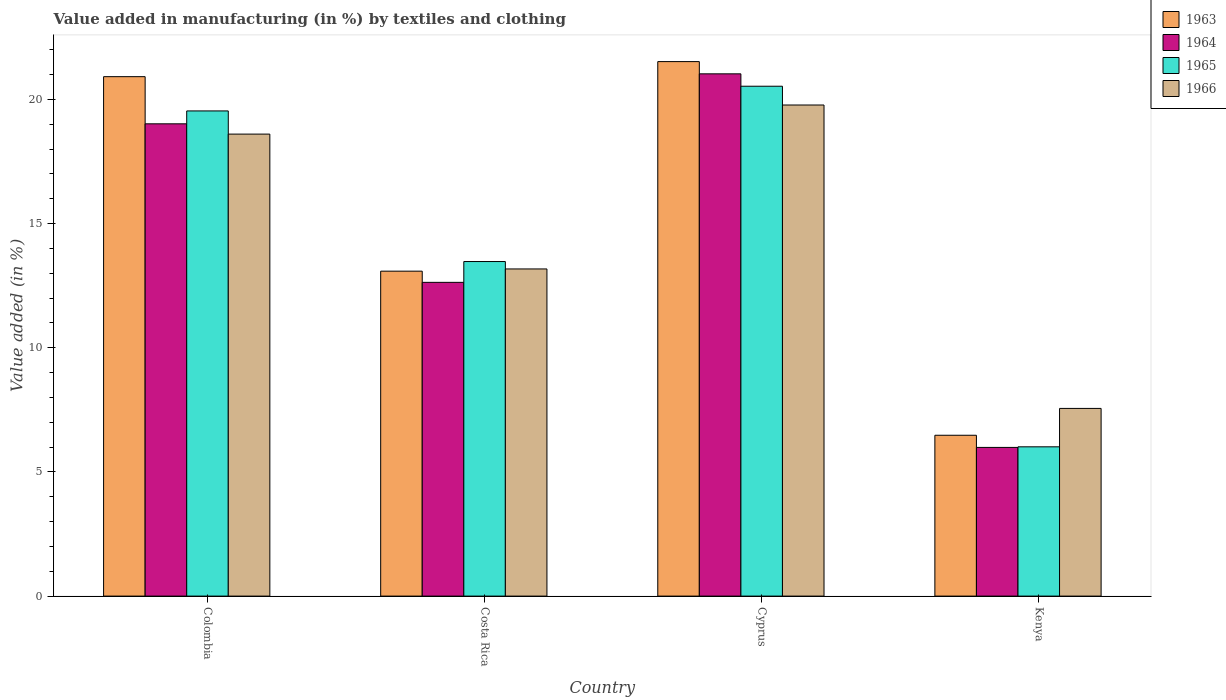How many different coloured bars are there?
Give a very brief answer. 4. How many groups of bars are there?
Ensure brevity in your answer.  4. How many bars are there on the 1st tick from the left?
Ensure brevity in your answer.  4. How many bars are there on the 1st tick from the right?
Make the answer very short. 4. What is the percentage of value added in manufacturing by textiles and clothing in 1964 in Colombia?
Offer a very short reply. 19.02. Across all countries, what is the maximum percentage of value added in manufacturing by textiles and clothing in 1966?
Provide a short and direct response. 19.78. Across all countries, what is the minimum percentage of value added in manufacturing by textiles and clothing in 1965?
Your answer should be compact. 6.01. In which country was the percentage of value added in manufacturing by textiles and clothing in 1963 maximum?
Give a very brief answer. Cyprus. In which country was the percentage of value added in manufacturing by textiles and clothing in 1963 minimum?
Provide a short and direct response. Kenya. What is the total percentage of value added in manufacturing by textiles and clothing in 1963 in the graph?
Provide a succinct answer. 62. What is the difference between the percentage of value added in manufacturing by textiles and clothing in 1965 in Cyprus and that in Kenya?
Your answer should be very brief. 14.52. What is the difference between the percentage of value added in manufacturing by textiles and clothing in 1966 in Costa Rica and the percentage of value added in manufacturing by textiles and clothing in 1963 in Colombia?
Your answer should be very brief. -7.74. What is the average percentage of value added in manufacturing by textiles and clothing in 1966 per country?
Offer a terse response. 14.78. What is the difference between the percentage of value added in manufacturing by textiles and clothing of/in 1964 and percentage of value added in manufacturing by textiles and clothing of/in 1963 in Kenya?
Offer a terse response. -0.49. What is the ratio of the percentage of value added in manufacturing by textiles and clothing in 1964 in Colombia to that in Cyprus?
Keep it short and to the point. 0.9. Is the percentage of value added in manufacturing by textiles and clothing in 1965 in Colombia less than that in Costa Rica?
Ensure brevity in your answer.  No. What is the difference between the highest and the second highest percentage of value added in manufacturing by textiles and clothing in 1965?
Offer a terse response. -0.99. What is the difference between the highest and the lowest percentage of value added in manufacturing by textiles and clothing in 1966?
Your answer should be compact. 12.22. Is it the case that in every country, the sum of the percentage of value added in manufacturing by textiles and clothing in 1966 and percentage of value added in manufacturing by textiles and clothing in 1963 is greater than the sum of percentage of value added in manufacturing by textiles and clothing in 1964 and percentage of value added in manufacturing by textiles and clothing in 1965?
Give a very brief answer. No. What does the 3rd bar from the right in Kenya represents?
Offer a terse response. 1964. Is it the case that in every country, the sum of the percentage of value added in manufacturing by textiles and clothing in 1963 and percentage of value added in manufacturing by textiles and clothing in 1965 is greater than the percentage of value added in manufacturing by textiles and clothing in 1966?
Your answer should be compact. Yes. Does the graph contain any zero values?
Provide a short and direct response. No. Does the graph contain grids?
Your response must be concise. No. How are the legend labels stacked?
Your response must be concise. Vertical. What is the title of the graph?
Your response must be concise. Value added in manufacturing (in %) by textiles and clothing. What is the label or title of the Y-axis?
Offer a terse response. Value added (in %). What is the Value added (in %) in 1963 in Colombia?
Offer a very short reply. 20.92. What is the Value added (in %) of 1964 in Colombia?
Provide a short and direct response. 19.02. What is the Value added (in %) of 1965 in Colombia?
Offer a terse response. 19.54. What is the Value added (in %) in 1966 in Colombia?
Your answer should be very brief. 18.6. What is the Value added (in %) of 1963 in Costa Rica?
Ensure brevity in your answer.  13.08. What is the Value added (in %) in 1964 in Costa Rica?
Your answer should be very brief. 12.63. What is the Value added (in %) of 1965 in Costa Rica?
Your response must be concise. 13.47. What is the Value added (in %) in 1966 in Costa Rica?
Make the answer very short. 13.17. What is the Value added (in %) of 1963 in Cyprus?
Your answer should be compact. 21.52. What is the Value added (in %) of 1964 in Cyprus?
Keep it short and to the point. 21.03. What is the Value added (in %) of 1965 in Cyprus?
Give a very brief answer. 20.53. What is the Value added (in %) of 1966 in Cyprus?
Offer a very short reply. 19.78. What is the Value added (in %) of 1963 in Kenya?
Keep it short and to the point. 6.48. What is the Value added (in %) in 1964 in Kenya?
Offer a terse response. 5.99. What is the Value added (in %) in 1965 in Kenya?
Your answer should be very brief. 6.01. What is the Value added (in %) in 1966 in Kenya?
Your answer should be very brief. 7.56. Across all countries, what is the maximum Value added (in %) in 1963?
Keep it short and to the point. 21.52. Across all countries, what is the maximum Value added (in %) of 1964?
Make the answer very short. 21.03. Across all countries, what is the maximum Value added (in %) of 1965?
Your response must be concise. 20.53. Across all countries, what is the maximum Value added (in %) in 1966?
Your response must be concise. 19.78. Across all countries, what is the minimum Value added (in %) in 1963?
Provide a short and direct response. 6.48. Across all countries, what is the minimum Value added (in %) of 1964?
Make the answer very short. 5.99. Across all countries, what is the minimum Value added (in %) of 1965?
Ensure brevity in your answer.  6.01. Across all countries, what is the minimum Value added (in %) in 1966?
Ensure brevity in your answer.  7.56. What is the total Value added (in %) in 1963 in the graph?
Offer a terse response. 62. What is the total Value added (in %) of 1964 in the graph?
Your answer should be compact. 58.67. What is the total Value added (in %) in 1965 in the graph?
Give a very brief answer. 59.55. What is the total Value added (in %) in 1966 in the graph?
Ensure brevity in your answer.  59.11. What is the difference between the Value added (in %) in 1963 in Colombia and that in Costa Rica?
Provide a short and direct response. 7.83. What is the difference between the Value added (in %) in 1964 in Colombia and that in Costa Rica?
Provide a succinct answer. 6.38. What is the difference between the Value added (in %) in 1965 in Colombia and that in Costa Rica?
Your response must be concise. 6.06. What is the difference between the Value added (in %) in 1966 in Colombia and that in Costa Rica?
Ensure brevity in your answer.  5.43. What is the difference between the Value added (in %) in 1963 in Colombia and that in Cyprus?
Provide a short and direct response. -0.61. What is the difference between the Value added (in %) of 1964 in Colombia and that in Cyprus?
Offer a terse response. -2.01. What is the difference between the Value added (in %) of 1965 in Colombia and that in Cyprus?
Provide a succinct answer. -0.99. What is the difference between the Value added (in %) in 1966 in Colombia and that in Cyprus?
Make the answer very short. -1.17. What is the difference between the Value added (in %) in 1963 in Colombia and that in Kenya?
Make the answer very short. 14.44. What is the difference between the Value added (in %) of 1964 in Colombia and that in Kenya?
Your answer should be very brief. 13.03. What is the difference between the Value added (in %) of 1965 in Colombia and that in Kenya?
Offer a very short reply. 13.53. What is the difference between the Value added (in %) in 1966 in Colombia and that in Kenya?
Your answer should be compact. 11.05. What is the difference between the Value added (in %) in 1963 in Costa Rica and that in Cyprus?
Provide a succinct answer. -8.44. What is the difference between the Value added (in %) of 1964 in Costa Rica and that in Cyprus?
Provide a succinct answer. -8.4. What is the difference between the Value added (in %) in 1965 in Costa Rica and that in Cyprus?
Give a very brief answer. -7.06. What is the difference between the Value added (in %) of 1966 in Costa Rica and that in Cyprus?
Provide a succinct answer. -6.6. What is the difference between the Value added (in %) in 1963 in Costa Rica and that in Kenya?
Offer a very short reply. 6.61. What is the difference between the Value added (in %) in 1964 in Costa Rica and that in Kenya?
Offer a terse response. 6.65. What is the difference between the Value added (in %) of 1965 in Costa Rica and that in Kenya?
Provide a short and direct response. 7.46. What is the difference between the Value added (in %) in 1966 in Costa Rica and that in Kenya?
Offer a terse response. 5.62. What is the difference between the Value added (in %) in 1963 in Cyprus and that in Kenya?
Provide a short and direct response. 15.05. What is the difference between the Value added (in %) of 1964 in Cyprus and that in Kenya?
Your answer should be very brief. 15.04. What is the difference between the Value added (in %) in 1965 in Cyprus and that in Kenya?
Ensure brevity in your answer.  14.52. What is the difference between the Value added (in %) in 1966 in Cyprus and that in Kenya?
Offer a very short reply. 12.22. What is the difference between the Value added (in %) in 1963 in Colombia and the Value added (in %) in 1964 in Costa Rica?
Your answer should be very brief. 8.28. What is the difference between the Value added (in %) in 1963 in Colombia and the Value added (in %) in 1965 in Costa Rica?
Provide a succinct answer. 7.44. What is the difference between the Value added (in %) of 1963 in Colombia and the Value added (in %) of 1966 in Costa Rica?
Your answer should be compact. 7.74. What is the difference between the Value added (in %) in 1964 in Colombia and the Value added (in %) in 1965 in Costa Rica?
Make the answer very short. 5.55. What is the difference between the Value added (in %) of 1964 in Colombia and the Value added (in %) of 1966 in Costa Rica?
Keep it short and to the point. 5.84. What is the difference between the Value added (in %) of 1965 in Colombia and the Value added (in %) of 1966 in Costa Rica?
Your response must be concise. 6.36. What is the difference between the Value added (in %) in 1963 in Colombia and the Value added (in %) in 1964 in Cyprus?
Your answer should be compact. -0.11. What is the difference between the Value added (in %) of 1963 in Colombia and the Value added (in %) of 1965 in Cyprus?
Offer a terse response. 0.39. What is the difference between the Value added (in %) in 1963 in Colombia and the Value added (in %) in 1966 in Cyprus?
Ensure brevity in your answer.  1.14. What is the difference between the Value added (in %) in 1964 in Colombia and the Value added (in %) in 1965 in Cyprus?
Your answer should be very brief. -1.51. What is the difference between the Value added (in %) of 1964 in Colombia and the Value added (in %) of 1966 in Cyprus?
Your answer should be compact. -0.76. What is the difference between the Value added (in %) in 1965 in Colombia and the Value added (in %) in 1966 in Cyprus?
Your response must be concise. -0.24. What is the difference between the Value added (in %) in 1963 in Colombia and the Value added (in %) in 1964 in Kenya?
Your answer should be compact. 14.93. What is the difference between the Value added (in %) of 1963 in Colombia and the Value added (in %) of 1965 in Kenya?
Give a very brief answer. 14.91. What is the difference between the Value added (in %) of 1963 in Colombia and the Value added (in %) of 1966 in Kenya?
Your answer should be compact. 13.36. What is the difference between the Value added (in %) of 1964 in Colombia and the Value added (in %) of 1965 in Kenya?
Your answer should be very brief. 13.01. What is the difference between the Value added (in %) in 1964 in Colombia and the Value added (in %) in 1966 in Kenya?
Your answer should be very brief. 11.46. What is the difference between the Value added (in %) in 1965 in Colombia and the Value added (in %) in 1966 in Kenya?
Offer a terse response. 11.98. What is the difference between the Value added (in %) in 1963 in Costa Rica and the Value added (in %) in 1964 in Cyprus?
Ensure brevity in your answer.  -7.95. What is the difference between the Value added (in %) in 1963 in Costa Rica and the Value added (in %) in 1965 in Cyprus?
Offer a very short reply. -7.45. What is the difference between the Value added (in %) in 1963 in Costa Rica and the Value added (in %) in 1966 in Cyprus?
Provide a short and direct response. -6.69. What is the difference between the Value added (in %) in 1964 in Costa Rica and the Value added (in %) in 1965 in Cyprus?
Ensure brevity in your answer.  -7.9. What is the difference between the Value added (in %) of 1964 in Costa Rica and the Value added (in %) of 1966 in Cyprus?
Give a very brief answer. -7.14. What is the difference between the Value added (in %) of 1965 in Costa Rica and the Value added (in %) of 1966 in Cyprus?
Provide a succinct answer. -6.3. What is the difference between the Value added (in %) in 1963 in Costa Rica and the Value added (in %) in 1964 in Kenya?
Provide a short and direct response. 7.1. What is the difference between the Value added (in %) in 1963 in Costa Rica and the Value added (in %) in 1965 in Kenya?
Provide a short and direct response. 7.07. What is the difference between the Value added (in %) of 1963 in Costa Rica and the Value added (in %) of 1966 in Kenya?
Offer a very short reply. 5.53. What is the difference between the Value added (in %) of 1964 in Costa Rica and the Value added (in %) of 1965 in Kenya?
Give a very brief answer. 6.62. What is the difference between the Value added (in %) in 1964 in Costa Rica and the Value added (in %) in 1966 in Kenya?
Your answer should be very brief. 5.08. What is the difference between the Value added (in %) in 1965 in Costa Rica and the Value added (in %) in 1966 in Kenya?
Offer a very short reply. 5.91. What is the difference between the Value added (in %) of 1963 in Cyprus and the Value added (in %) of 1964 in Kenya?
Provide a short and direct response. 15.54. What is the difference between the Value added (in %) in 1963 in Cyprus and the Value added (in %) in 1965 in Kenya?
Your answer should be compact. 15.51. What is the difference between the Value added (in %) in 1963 in Cyprus and the Value added (in %) in 1966 in Kenya?
Ensure brevity in your answer.  13.97. What is the difference between the Value added (in %) in 1964 in Cyprus and the Value added (in %) in 1965 in Kenya?
Ensure brevity in your answer.  15.02. What is the difference between the Value added (in %) in 1964 in Cyprus and the Value added (in %) in 1966 in Kenya?
Your answer should be compact. 13.47. What is the difference between the Value added (in %) in 1965 in Cyprus and the Value added (in %) in 1966 in Kenya?
Provide a succinct answer. 12.97. What is the average Value added (in %) of 1963 per country?
Your answer should be compact. 15.5. What is the average Value added (in %) of 1964 per country?
Make the answer very short. 14.67. What is the average Value added (in %) of 1965 per country?
Ensure brevity in your answer.  14.89. What is the average Value added (in %) in 1966 per country?
Keep it short and to the point. 14.78. What is the difference between the Value added (in %) of 1963 and Value added (in %) of 1964 in Colombia?
Offer a terse response. 1.9. What is the difference between the Value added (in %) in 1963 and Value added (in %) in 1965 in Colombia?
Provide a short and direct response. 1.38. What is the difference between the Value added (in %) in 1963 and Value added (in %) in 1966 in Colombia?
Offer a terse response. 2.31. What is the difference between the Value added (in %) in 1964 and Value added (in %) in 1965 in Colombia?
Offer a very short reply. -0.52. What is the difference between the Value added (in %) in 1964 and Value added (in %) in 1966 in Colombia?
Keep it short and to the point. 0.41. What is the difference between the Value added (in %) of 1965 and Value added (in %) of 1966 in Colombia?
Give a very brief answer. 0.93. What is the difference between the Value added (in %) of 1963 and Value added (in %) of 1964 in Costa Rica?
Provide a short and direct response. 0.45. What is the difference between the Value added (in %) of 1963 and Value added (in %) of 1965 in Costa Rica?
Keep it short and to the point. -0.39. What is the difference between the Value added (in %) in 1963 and Value added (in %) in 1966 in Costa Rica?
Provide a succinct answer. -0.09. What is the difference between the Value added (in %) in 1964 and Value added (in %) in 1965 in Costa Rica?
Your answer should be compact. -0.84. What is the difference between the Value added (in %) in 1964 and Value added (in %) in 1966 in Costa Rica?
Your answer should be compact. -0.54. What is the difference between the Value added (in %) of 1965 and Value added (in %) of 1966 in Costa Rica?
Offer a very short reply. 0.3. What is the difference between the Value added (in %) in 1963 and Value added (in %) in 1964 in Cyprus?
Provide a short and direct response. 0.49. What is the difference between the Value added (in %) in 1963 and Value added (in %) in 1965 in Cyprus?
Provide a short and direct response. 0.99. What is the difference between the Value added (in %) of 1963 and Value added (in %) of 1966 in Cyprus?
Ensure brevity in your answer.  1.75. What is the difference between the Value added (in %) in 1964 and Value added (in %) in 1965 in Cyprus?
Give a very brief answer. 0.5. What is the difference between the Value added (in %) of 1964 and Value added (in %) of 1966 in Cyprus?
Ensure brevity in your answer.  1.25. What is the difference between the Value added (in %) in 1965 and Value added (in %) in 1966 in Cyprus?
Provide a succinct answer. 0.76. What is the difference between the Value added (in %) in 1963 and Value added (in %) in 1964 in Kenya?
Provide a short and direct response. 0.49. What is the difference between the Value added (in %) in 1963 and Value added (in %) in 1965 in Kenya?
Your response must be concise. 0.47. What is the difference between the Value added (in %) in 1963 and Value added (in %) in 1966 in Kenya?
Offer a terse response. -1.08. What is the difference between the Value added (in %) in 1964 and Value added (in %) in 1965 in Kenya?
Your answer should be compact. -0.02. What is the difference between the Value added (in %) of 1964 and Value added (in %) of 1966 in Kenya?
Make the answer very short. -1.57. What is the difference between the Value added (in %) of 1965 and Value added (in %) of 1966 in Kenya?
Your response must be concise. -1.55. What is the ratio of the Value added (in %) in 1963 in Colombia to that in Costa Rica?
Your answer should be compact. 1.6. What is the ratio of the Value added (in %) of 1964 in Colombia to that in Costa Rica?
Keep it short and to the point. 1.51. What is the ratio of the Value added (in %) of 1965 in Colombia to that in Costa Rica?
Your answer should be very brief. 1.45. What is the ratio of the Value added (in %) of 1966 in Colombia to that in Costa Rica?
Your answer should be very brief. 1.41. What is the ratio of the Value added (in %) in 1963 in Colombia to that in Cyprus?
Give a very brief answer. 0.97. What is the ratio of the Value added (in %) in 1964 in Colombia to that in Cyprus?
Ensure brevity in your answer.  0.9. What is the ratio of the Value added (in %) in 1965 in Colombia to that in Cyprus?
Your answer should be compact. 0.95. What is the ratio of the Value added (in %) in 1966 in Colombia to that in Cyprus?
Ensure brevity in your answer.  0.94. What is the ratio of the Value added (in %) in 1963 in Colombia to that in Kenya?
Make the answer very short. 3.23. What is the ratio of the Value added (in %) of 1964 in Colombia to that in Kenya?
Keep it short and to the point. 3.18. What is the ratio of the Value added (in %) of 1965 in Colombia to that in Kenya?
Ensure brevity in your answer.  3.25. What is the ratio of the Value added (in %) in 1966 in Colombia to that in Kenya?
Your response must be concise. 2.46. What is the ratio of the Value added (in %) in 1963 in Costa Rica to that in Cyprus?
Provide a succinct answer. 0.61. What is the ratio of the Value added (in %) of 1964 in Costa Rica to that in Cyprus?
Provide a succinct answer. 0.6. What is the ratio of the Value added (in %) in 1965 in Costa Rica to that in Cyprus?
Give a very brief answer. 0.66. What is the ratio of the Value added (in %) in 1966 in Costa Rica to that in Cyprus?
Offer a very short reply. 0.67. What is the ratio of the Value added (in %) in 1963 in Costa Rica to that in Kenya?
Give a very brief answer. 2.02. What is the ratio of the Value added (in %) in 1964 in Costa Rica to that in Kenya?
Give a very brief answer. 2.11. What is the ratio of the Value added (in %) of 1965 in Costa Rica to that in Kenya?
Keep it short and to the point. 2.24. What is the ratio of the Value added (in %) of 1966 in Costa Rica to that in Kenya?
Keep it short and to the point. 1.74. What is the ratio of the Value added (in %) in 1963 in Cyprus to that in Kenya?
Make the answer very short. 3.32. What is the ratio of the Value added (in %) in 1964 in Cyprus to that in Kenya?
Offer a terse response. 3.51. What is the ratio of the Value added (in %) in 1965 in Cyprus to that in Kenya?
Offer a terse response. 3.42. What is the ratio of the Value added (in %) in 1966 in Cyprus to that in Kenya?
Offer a terse response. 2.62. What is the difference between the highest and the second highest Value added (in %) in 1963?
Give a very brief answer. 0.61. What is the difference between the highest and the second highest Value added (in %) in 1964?
Offer a terse response. 2.01. What is the difference between the highest and the second highest Value added (in %) in 1965?
Make the answer very short. 0.99. What is the difference between the highest and the second highest Value added (in %) of 1966?
Provide a succinct answer. 1.17. What is the difference between the highest and the lowest Value added (in %) in 1963?
Offer a very short reply. 15.05. What is the difference between the highest and the lowest Value added (in %) of 1964?
Provide a short and direct response. 15.04. What is the difference between the highest and the lowest Value added (in %) in 1965?
Offer a terse response. 14.52. What is the difference between the highest and the lowest Value added (in %) in 1966?
Your answer should be very brief. 12.22. 